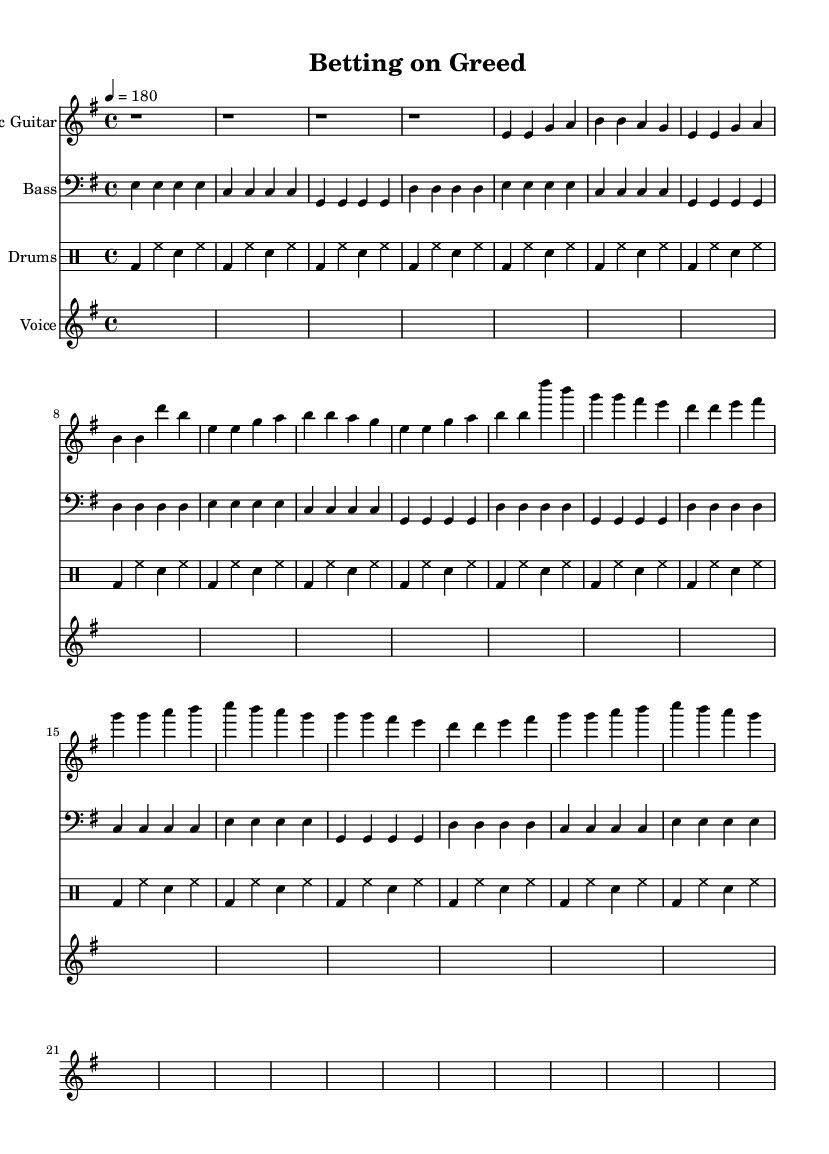What is the key signature of this music? The key signature is indicated at the beginning of the staff, showing 1 sharp, which represents E minor.
Answer: E minor What is the time signature of the piece? The time signature is found at the beginning of the staff, denoted by the 4 over 4, indicating common time.
Answer: 4/4 What is the tempo of the song? The tempo marking indicates the speed of the song, which is set to 180 beats per minute, as shown at the start of the music.
Answer: 180 How many measures are in the chorus section? The chorus consists of 4 measures, starting with the first line of chords and continuing for another three lines, each containing 4 beats.
Answer: 4 What instrument is primarily used for the melody in this song? The instrument playing the melody is specified at the beginning of the music; in this case, it is the electric guitar, which typically carries the primary melody in punk songs.
Answer: Electric Guitar Which lyrical theme is represented in the chorus? The theme in the chorus addresses the commercialization of horse racing, as it mentions betting on greed and the loss of the sport's true value.
Answer: Commercialization How many beats are played in the intro? The intro consists of 4 measures; each measure contains 4 beats for a total of 16 beats played.
Answer: 16 